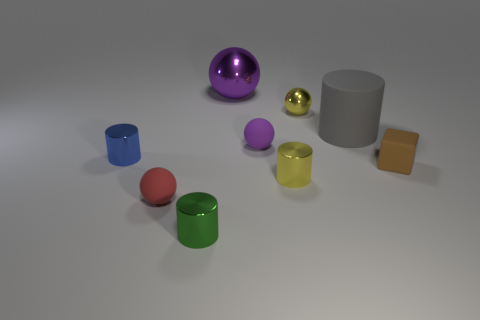Subtract 1 cylinders. How many cylinders are left? 3 Subtract all balls. How many objects are left? 5 Subtract all tiny balls. Subtract all spheres. How many objects are left? 2 Add 1 small brown rubber objects. How many small brown rubber objects are left? 2 Add 6 yellow shiny balls. How many yellow shiny balls exist? 7 Subtract 0 gray blocks. How many objects are left? 9 